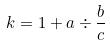Convert formula to latex. <formula><loc_0><loc_0><loc_500><loc_500>k = 1 + a \div \frac { b } { c }</formula> 